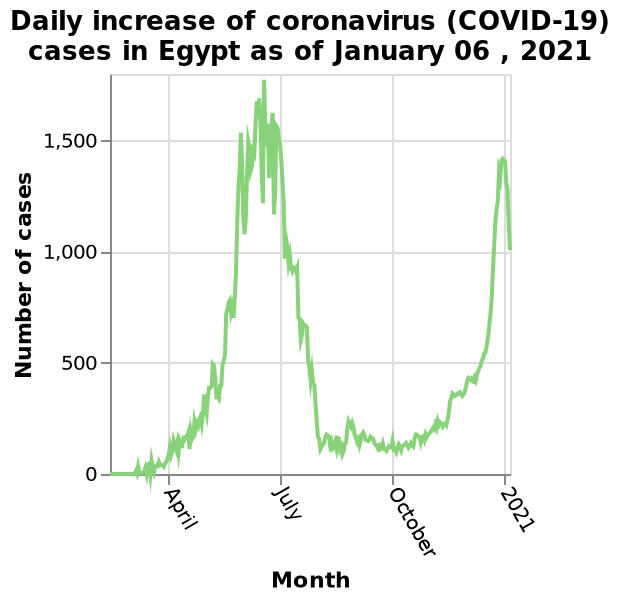<image>
How can you describe the overall trend of the line graph? The overall trend of the line graph represents the fluctuations and changes in the daily increase of coronavirus cases in Egypt from April to January 06, 2021. Without specific values or data points, the exact trend cannot be described. What country experienced the highest number of coronavirus cases in July 2021? Egypt experienced the highest number of coronavirus cases in July 2021. 